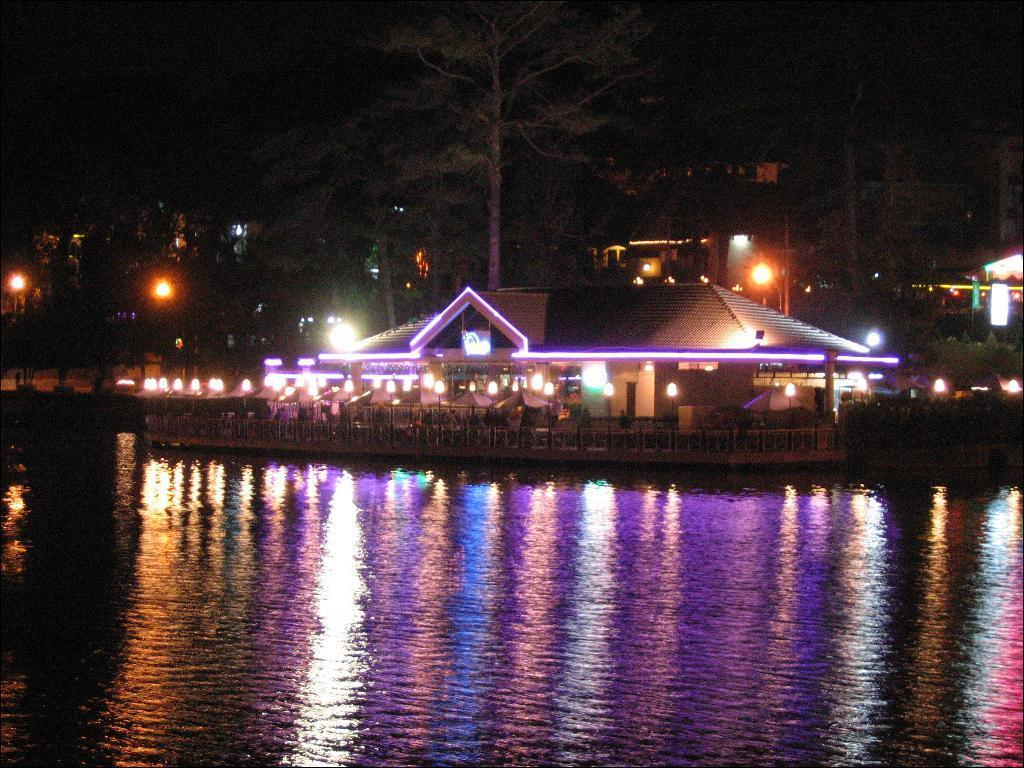What type of structures can be seen in the image? There are houses in the image. What objects are providing illumination in the image? There are lights in the image. What type of vegetation is present in the image? There are plants and trees in the image. What natural element can be seen at the bottom of the image? There is water visible at the bottom of the image. How would you describe the overall lighting in the image? The background of the image is dark. What type of pleasure can be seen in the image? There is no specific pleasure depicted in the image; it features houses, lights, plants, trees, water, and a dark background. What is the source of fear in the image? There is no fear depicted in the image; it does not show any threatening or scary elements. 